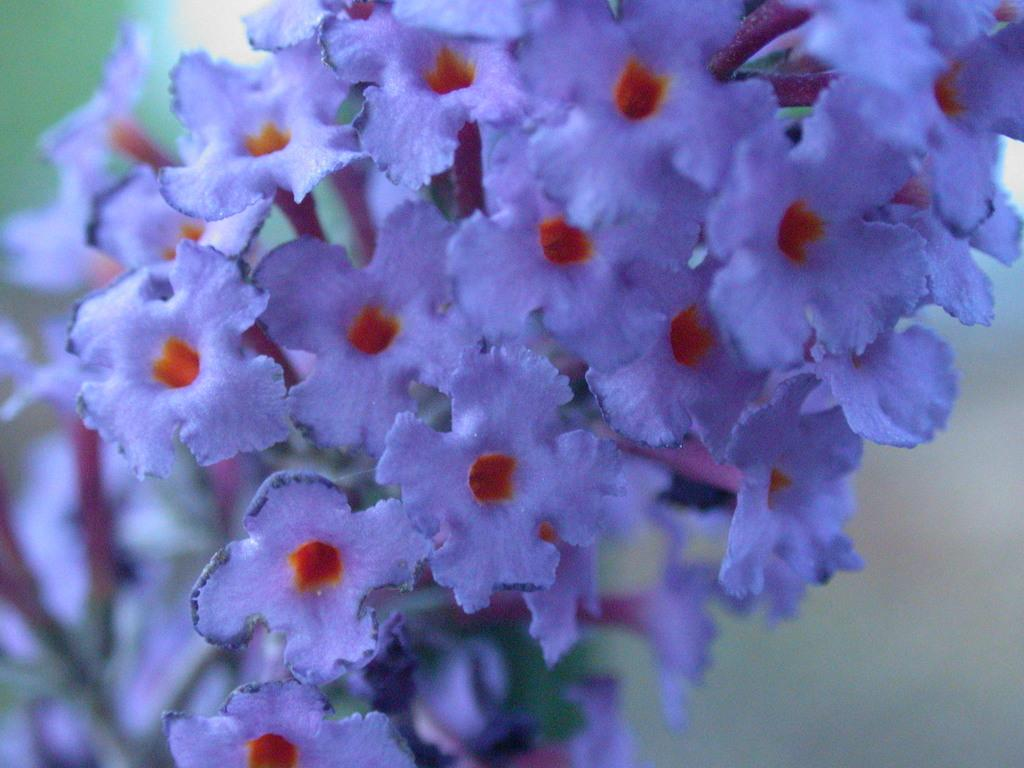What is the main subject of the image? The main subject of the image is a close-up of flowers. Can you describe the color of the flowers in the image? There are blue flowers in the image. How many times are the flowers twisted in the image? The flowers are not twisted in the image; they are shown in a close-up view. What type of nail is used to hold the flowers in the image? There are no nails present in the image, as it is a close-up of flowers without any additional objects or context. 